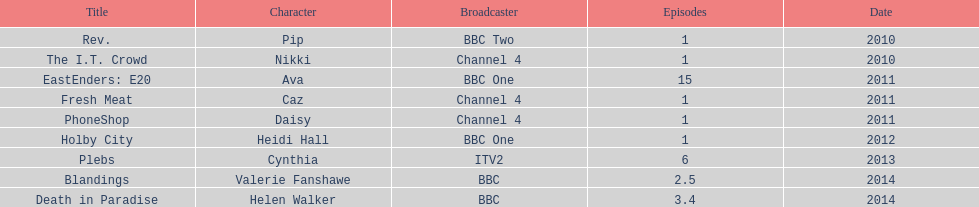Before assuming the role of cynthia in plebs, what character did this actress previously perform? Heidi Hall. 